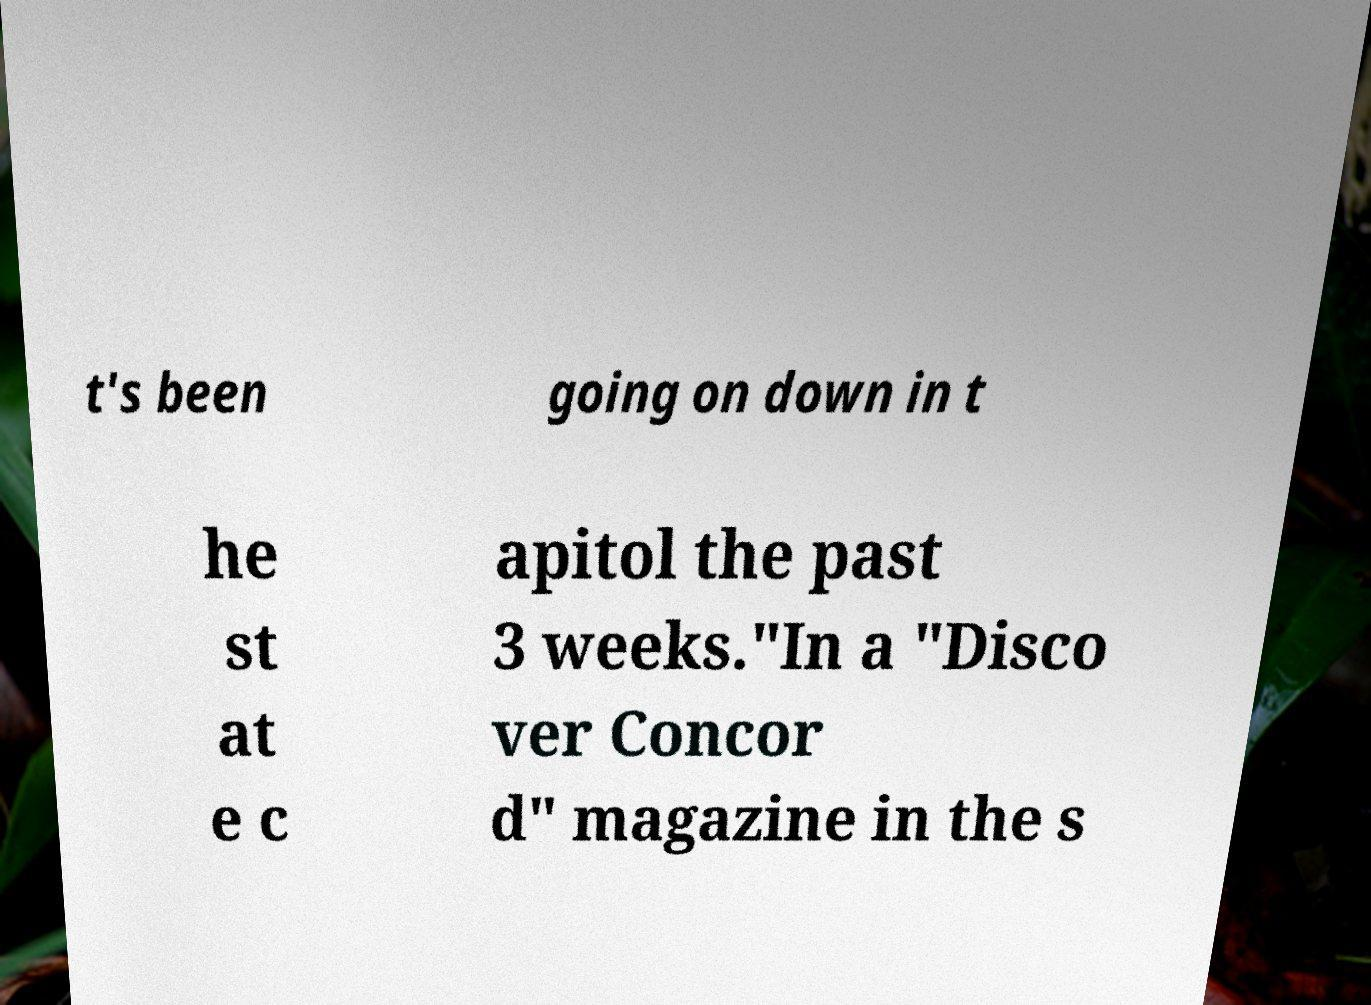Could you assist in decoding the text presented in this image and type it out clearly? t's been going on down in t he st at e c apitol the past 3 weeks."In a "Disco ver Concor d" magazine in the s 